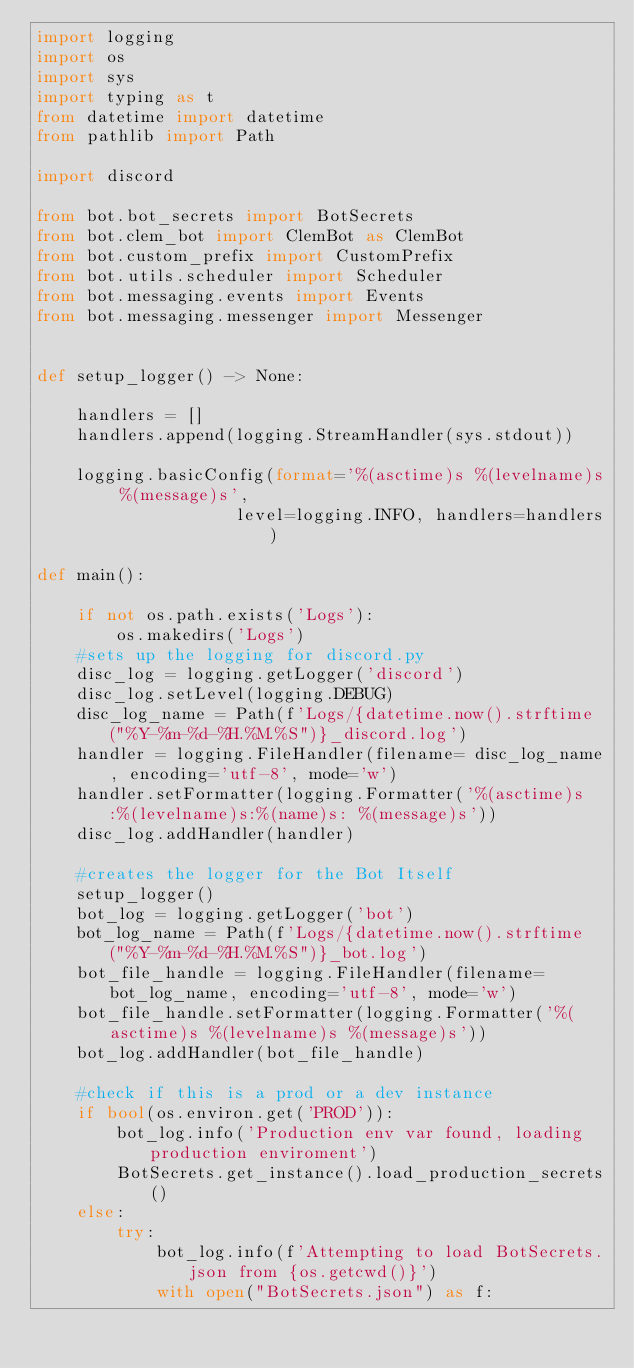Convert code to text. <code><loc_0><loc_0><loc_500><loc_500><_Python_>import logging
import os
import sys
import typing as t
from datetime import datetime
from pathlib import Path

import discord

from bot.bot_secrets import BotSecrets
from bot.clem_bot import ClemBot as ClemBot
from bot.custom_prefix import CustomPrefix
from bot.utils.scheduler import Scheduler
from bot.messaging.events import Events
from bot.messaging.messenger import Messenger


def setup_logger() -> None:

    handlers = []
    handlers.append(logging.StreamHandler(sys.stdout))

    logging.basicConfig(format='%(asctime)s %(levelname)s %(message)s',
                    level=logging.INFO, handlers=handlers)

def main():

    if not os.path.exists('Logs'):
        os.makedirs('Logs')
    #sets up the logging for discord.py
    disc_log = logging.getLogger('discord')
    disc_log.setLevel(logging.DEBUG)
    disc_log_name = Path(f'Logs/{datetime.now().strftime("%Y-%m-%d-%H.%M.%S")}_discord.log')
    handler = logging.FileHandler(filename= disc_log_name, encoding='utf-8', mode='w')
    handler.setFormatter(logging.Formatter('%(asctime)s:%(levelname)s:%(name)s: %(message)s'))
    disc_log.addHandler(handler)

    #creates the logger for the Bot Itself
    setup_logger()
    bot_log = logging.getLogger('bot')
    bot_log_name = Path(f'Logs/{datetime.now().strftime("%Y-%m-%d-%H.%M.%S")}_bot.log')
    bot_file_handle = logging.FileHandler(filename= bot_log_name, encoding='utf-8', mode='w')
    bot_file_handle.setFormatter(logging.Formatter('%(asctime)s %(levelname)s %(message)s'))
    bot_log.addHandler(bot_file_handle)

    #check if this is a prod or a dev instance
    if bool(os.environ.get('PROD')):
        bot_log.info('Production env var found, loading production enviroment')
        BotSecrets.get_instance().load_production_secrets()
    else:
        try:
            bot_log.info(f'Attempting to load BotSecrets.json from {os.getcwd()}')
            with open("BotSecrets.json") as f:</code> 